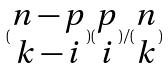Convert formula to latex. <formula><loc_0><loc_0><loc_500><loc_500>( \begin{matrix} n - p \\ k - i \end{matrix} ) ( \begin{matrix} p \\ i \end{matrix} ) / ( \begin{matrix} n \\ k \end{matrix} )</formula> 